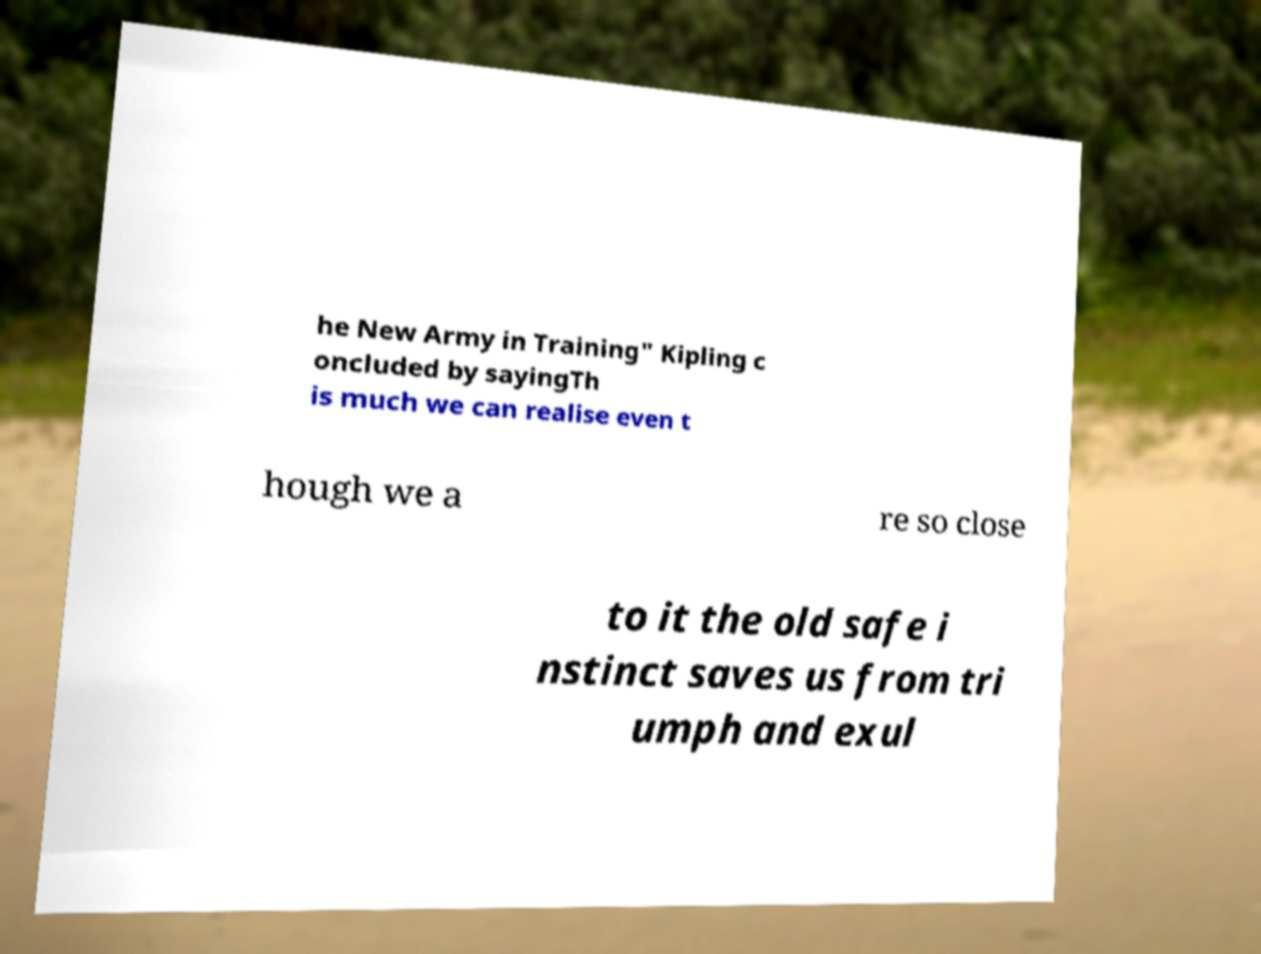Could you assist in decoding the text presented in this image and type it out clearly? he New Army in Training" Kipling c oncluded by sayingTh is much we can realise even t hough we a re so close to it the old safe i nstinct saves us from tri umph and exul 